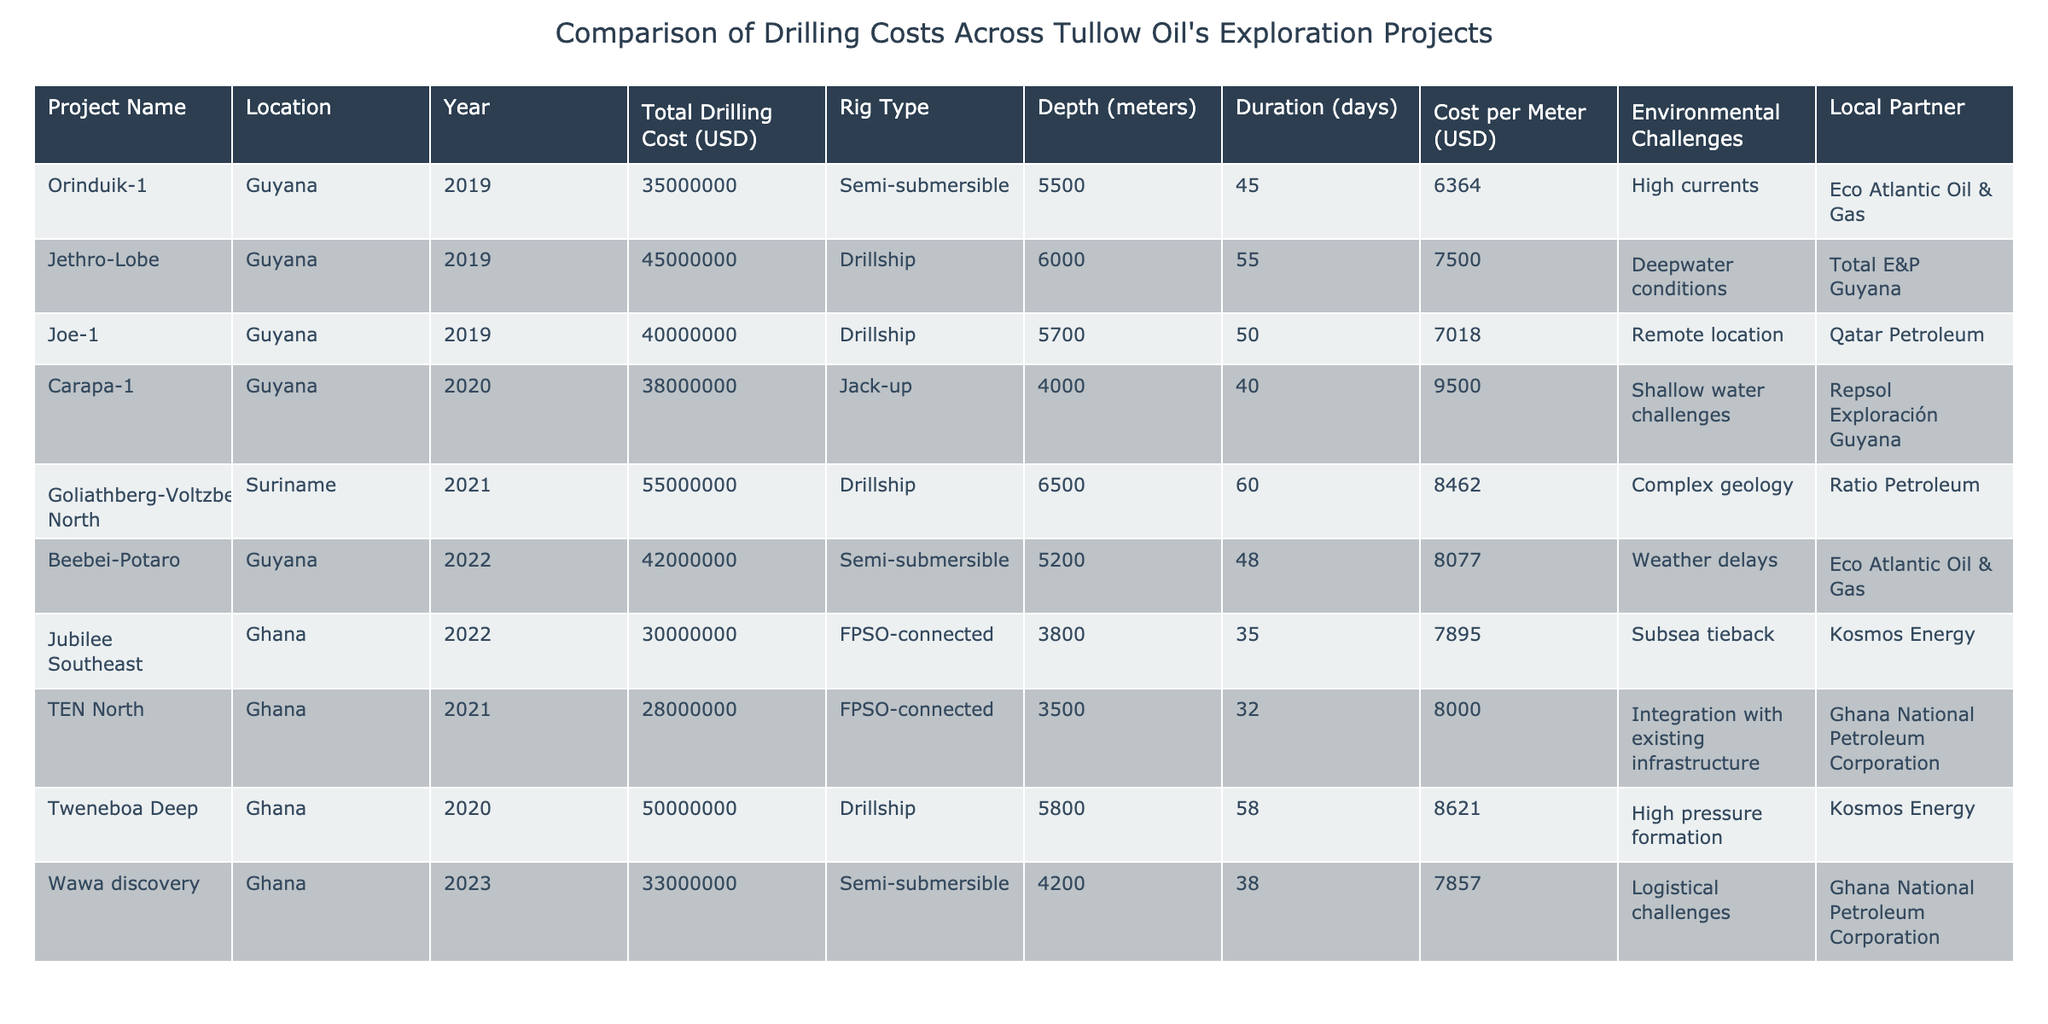What is the total drilling cost for the Joe-1 project? The Joe-1 project is listed in the table with a total drilling cost of 40,000,000 USD.
Answer: 40,000,000 USD Which project had the highest cost per meter? The Goliathberg-Voltzberg North project has the highest cost per meter at 8,462 USD.
Answer: 8,462 USD How many days did the Orinduik-1 project take for drilling? The table indicates that the Orinduik-1 project took 45 days for drilling.
Answer: 45 days What is the average total drilling cost of the projects located in Ghana? The total drilling costs for Ghana projects are 30,000,000 + 28,000,000 + 50,000,000 = 108,000,000 USD. There are 3 projects, so the average cost is 108,000,000 / 3 = 36,000,000 USD.
Answer: 36,000,000 USD Did any projects face environmental challenges? Yes, several projects faced environmental challenges, including high currents and complex geology.
Answer: Yes Which project had the longest drilling duration? The Jethro-Lobe project lasted 55 days, making it the longest drilling duration.
Answer: 55 days What is the average cost per meter for the drillships used in the projects? The cost per meter for drillships are 7,500, 7,018, 8,462, and 8,621. The average is (7,500 + 7,018 + 8,462 + 8,621) / 4 = 7,650.25 USD.
Answer: 7,650.25 USD Which project had the lowest total drilling cost? The Jubilee Southeast project had the lowest total drilling cost at 30,000,000 USD.
Answer: 30,000,000 USD How many projects involved a local partner? All projects listed in the table have a local partner associated with them.
Answer: All projects Which location had the majority of the projects? The majority of the projects are located in Guyana, with four out of the ten total projects.
Answer: Guyana 